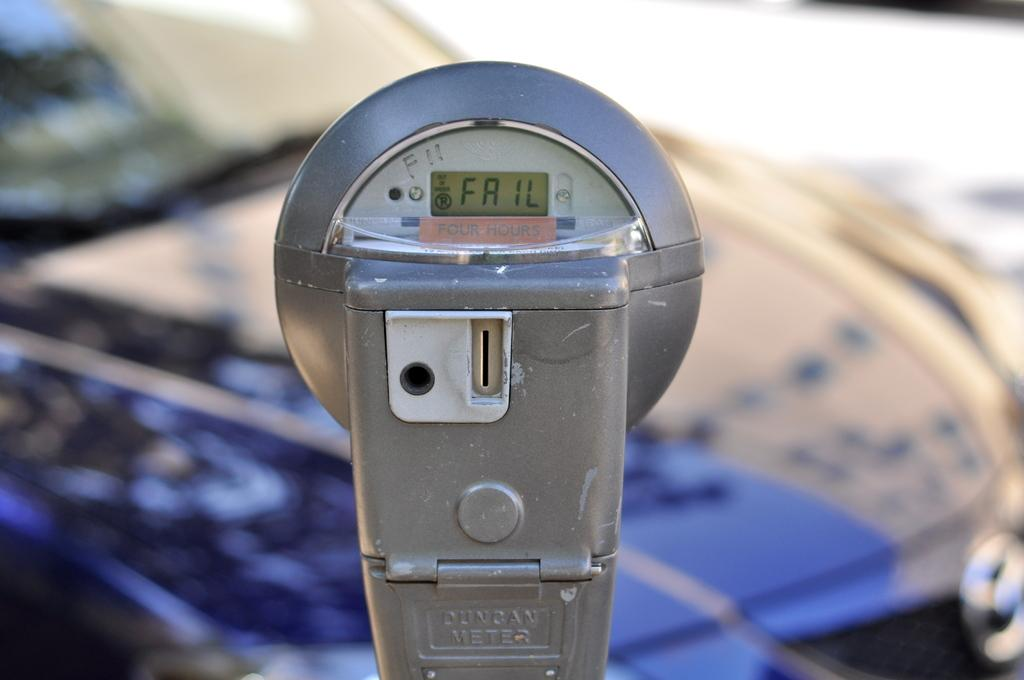<image>
Render a clear and concise summary of the photo. a parking meter with the words FAIL on it 